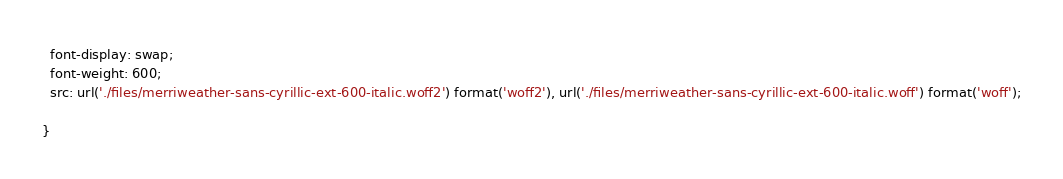Convert code to text. <code><loc_0><loc_0><loc_500><loc_500><_CSS_>  font-display: swap;
  font-weight: 600;
  src: url('./files/merriweather-sans-cyrillic-ext-600-italic.woff2') format('woff2'), url('./files/merriweather-sans-cyrillic-ext-600-italic.woff') format('woff');
  
}
</code> 